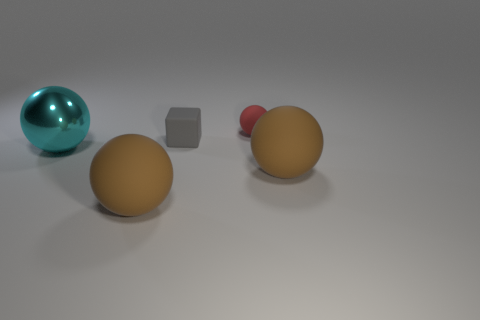Does the image seem to express any particular mood or atmosphere? The image has a subdued and neutral tone because of its muted colors and soft lighting. The plain grey background creates an abstract, minimalistic feel that is open to interpretation. The composition of objects is balanced, adding to the calm and ordered atmosphere of the scene. 